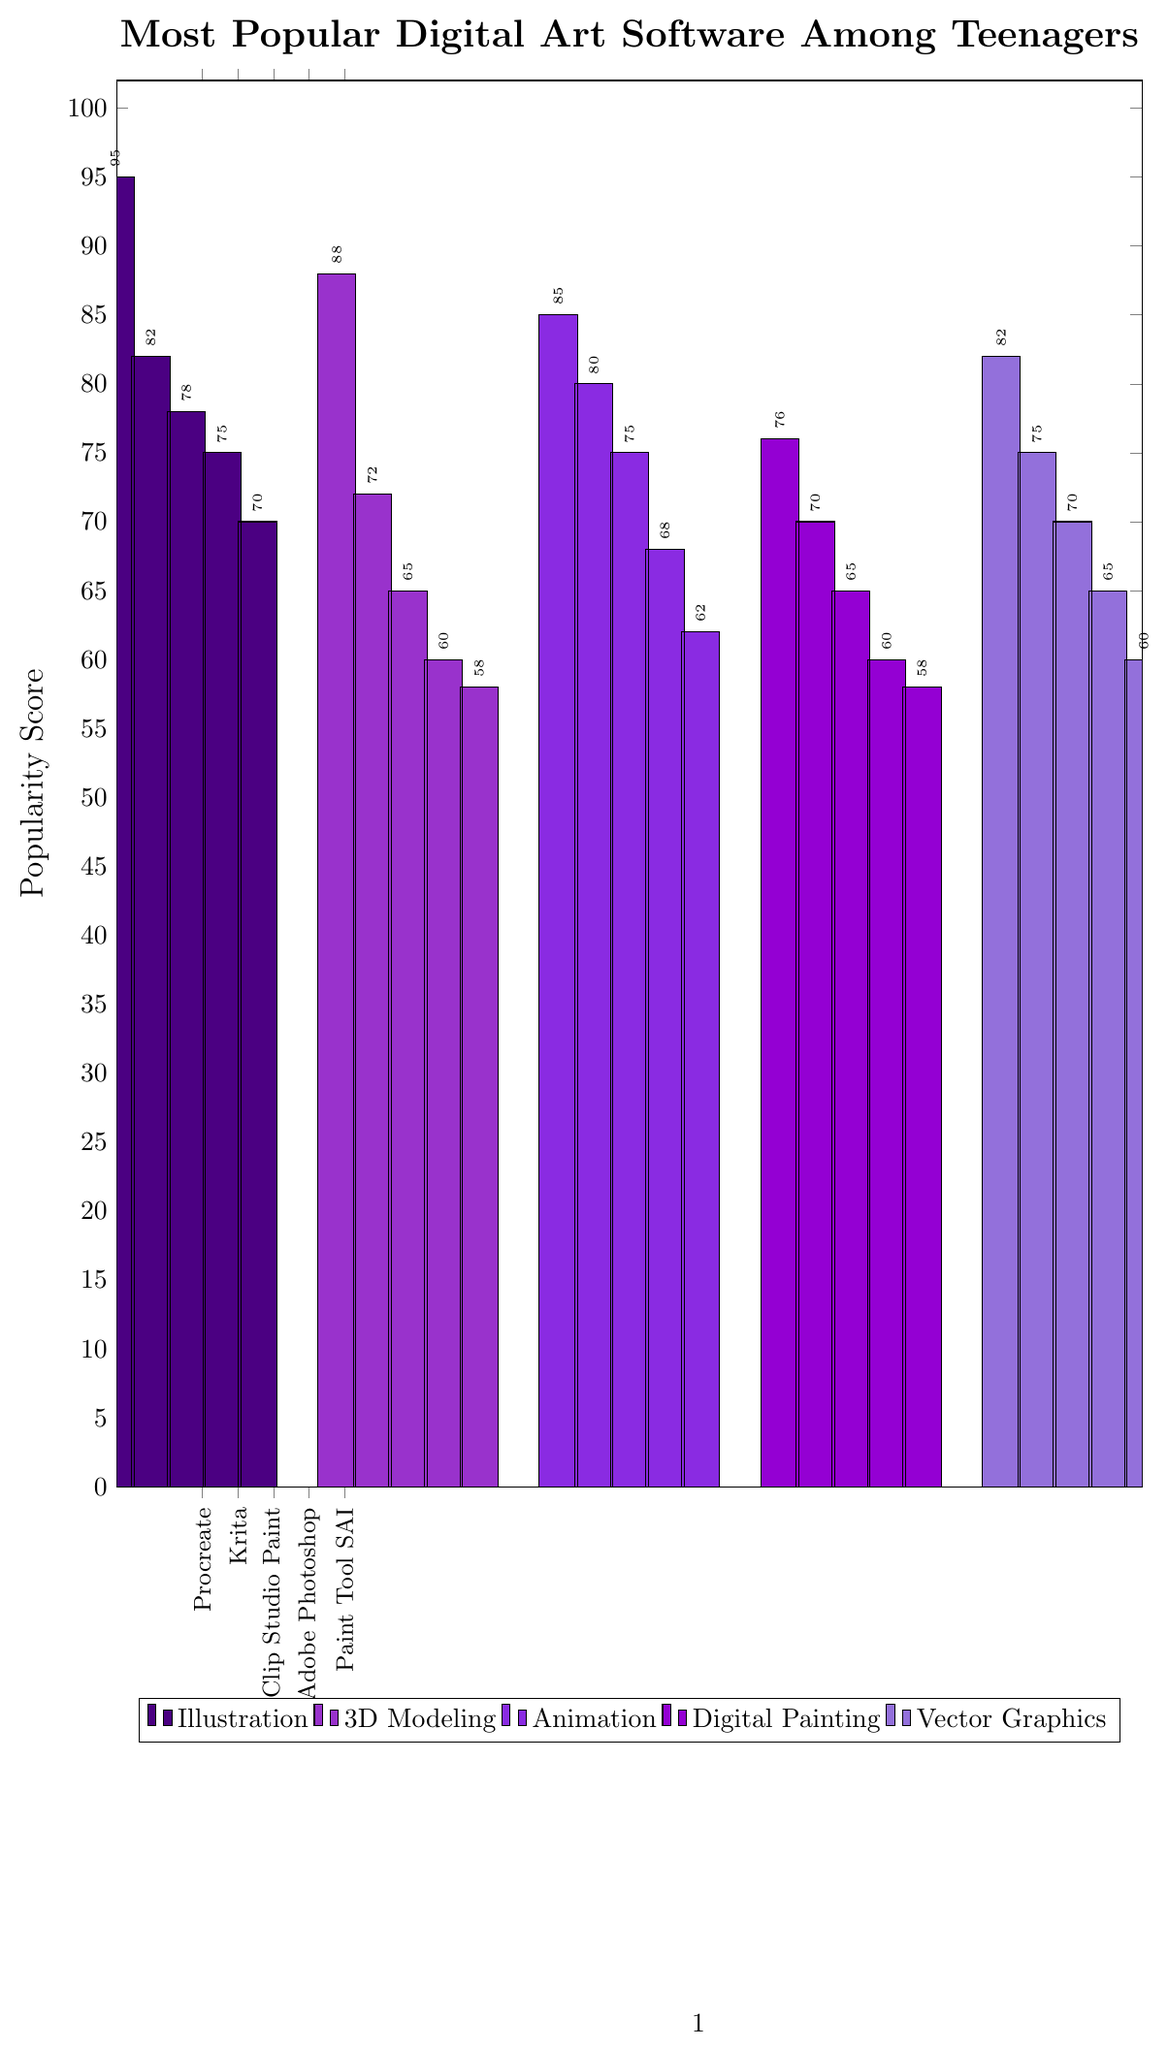What is the most popular digital art software for illustration among teenagers? The bar for Procreate in the Illustration category is the tallest, indicating it has the highest popularity score.
Answer: Procreate Which 3D modeling software is the least popular among teenagers? The bar for ZBrush in the 3D Modeling category is the shortest, indicating it has the lowest popularity score.
Answer: ZBrush How much more popular is Adobe Animate compared to OpenToonz? Adobe Animate has a popularity score of 85, while OpenToonz has a score of 75. Subtracting OpenToonz's score from Adobe Animate's gives 85 - 75 = 10.
Answer: 10 Which category has the software with the highest popularity score? The highest popularity score is 95, which is in the Illustration category for Procreate.
Answer: Illustration What is the average popularity score of the software in the Digital Painting category? The popularity scores in the Digital Painting category are 76, 70, 65, 60, and 58. The average is calculated by summing these scores and dividing by the number of software: (76 + 70 + 65 + 60 + 58) / 5 = 65.8.
Answer: 65.8 Which vector graphics software has a higher popularity score, Affinity Designer or CorelDRAW? Affinity Designer has a popularity score of 75, while CorelDRAW has a score of 65. Therefore, Affinity Designer has a higher score.
Answer: Affinity Designer What is the total popularity score of all the animation software listed? The popularity scores in the Animation category are 85, 80, 75, 68, and 62. The total is 85 + 80 + 75 + 68 + 62 = 370.
Answer: 370 How does the popularity of Blender compare to that of SketchUp? Blender has a popularity score of 88, and SketchUp has a score of 72. Therefore, Blender is more popular than SketchUp.
Answer: Blender Among the least popular software in each category, which one has the highest popularity score? The least popular software in each category are Paint Tool SAI (70) for Illustration, ZBrush (58) for 3D Modeling, Pencil2D (62) for Animation, MediBang Paint (58) for Digital Painting, and Gravit Designer (60) for Vector Graphics. Among these, Paint Tool SAI has the highest score of 70.
Answer: Paint Tool SAI 